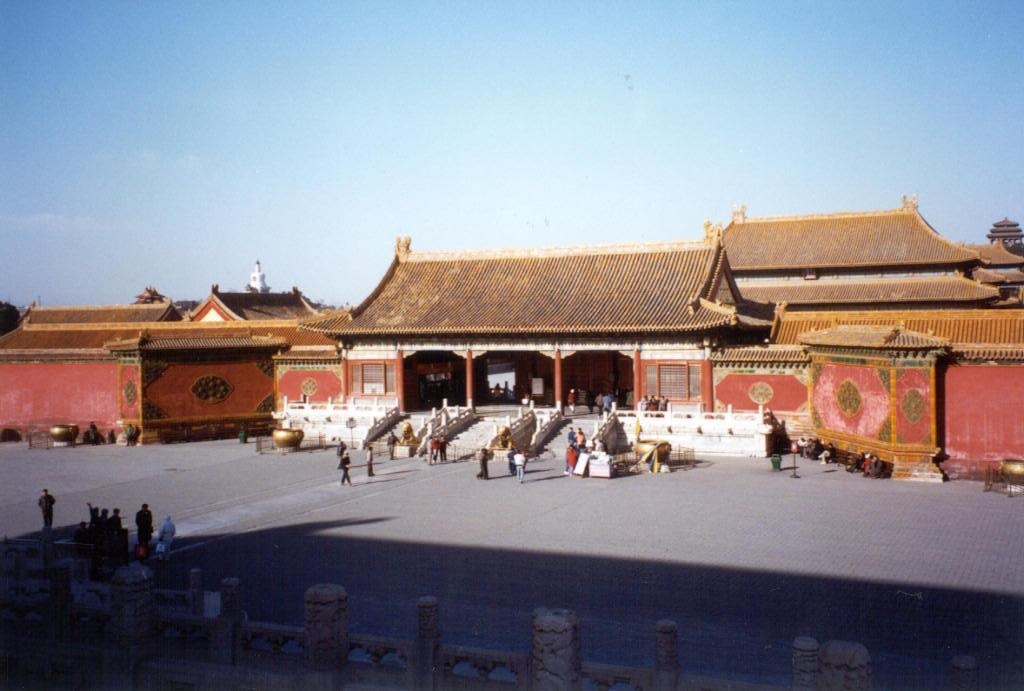What type of structures can be seen in the image? There are houses in the image. What architectural feature is present in the image? There are stairs and railings in the image. Who or what is present in the image? There are people and objects in the image. What is the setting of the image? There is a road in the image, and the sky is visible in the background. What additional feature can be seen at the bottom of the image? Pillars are visible at the bottom of the image. What type of prose can be seen on the houses in the image? There is no prose visible on the houses in the image. How many roses are present in the image? There are no roses visible in the image. 